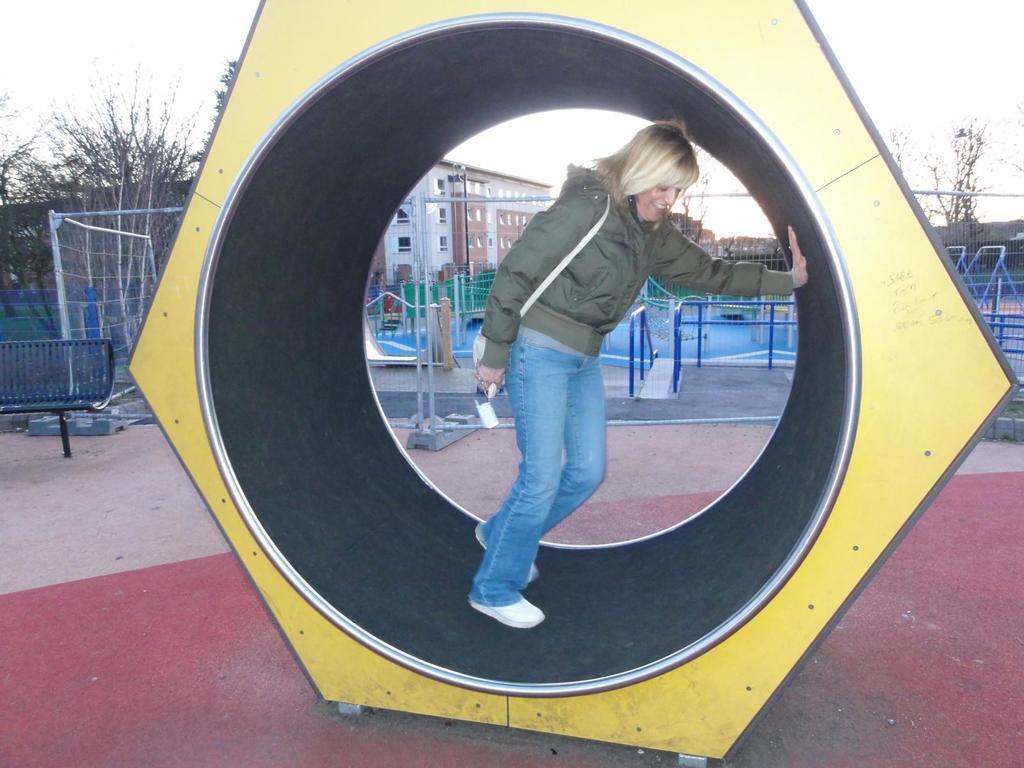Could you give a brief overview of what you see in this image? In this image we can see a woman standing on the floor, bench, grills, buildings, trees, fences and sky. 